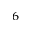<formula> <loc_0><loc_0><loc_500><loc_500>^ { 6 }</formula> 